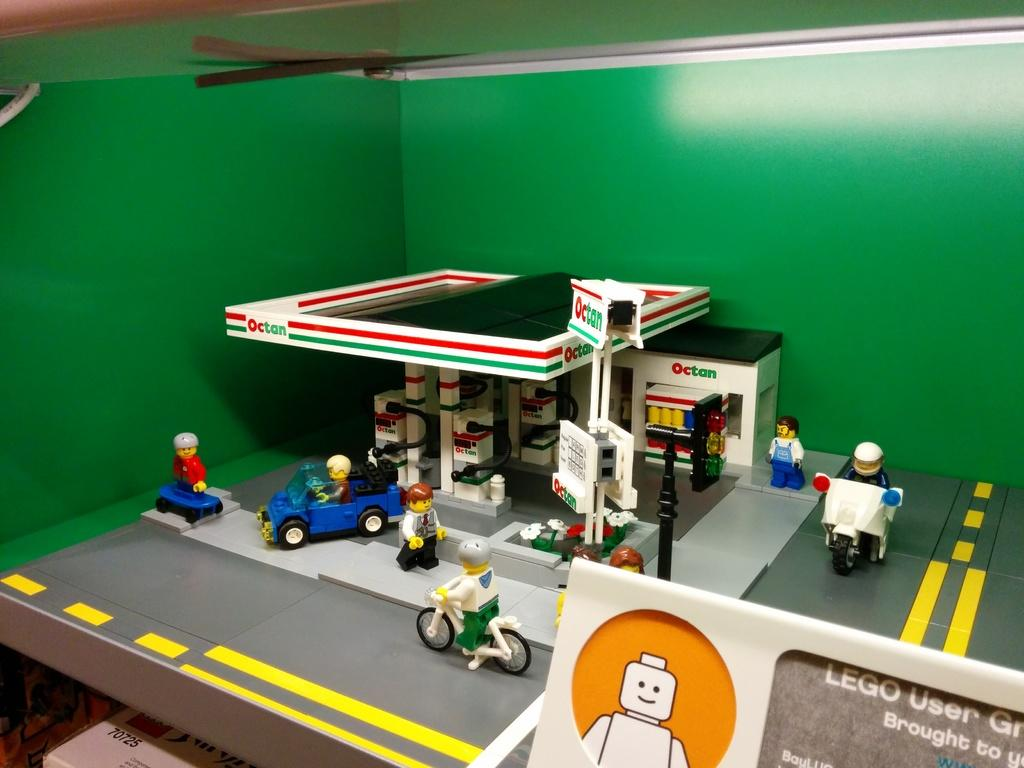What is the main object in the image? There is a cardboard in the image. What is inside the cardboard? The cardboard is filled with toys. What theme do the toys represent? The toys represent a petrol place. Is there any text or label on the cardboard? Yes, there is a label called "LEGO USER" on the right side of the image. What type of canvas is being used to create the skirt in the image? There is no canvas or skirt present in the image; it features a cardboard filled with LEGO toys and a label. 